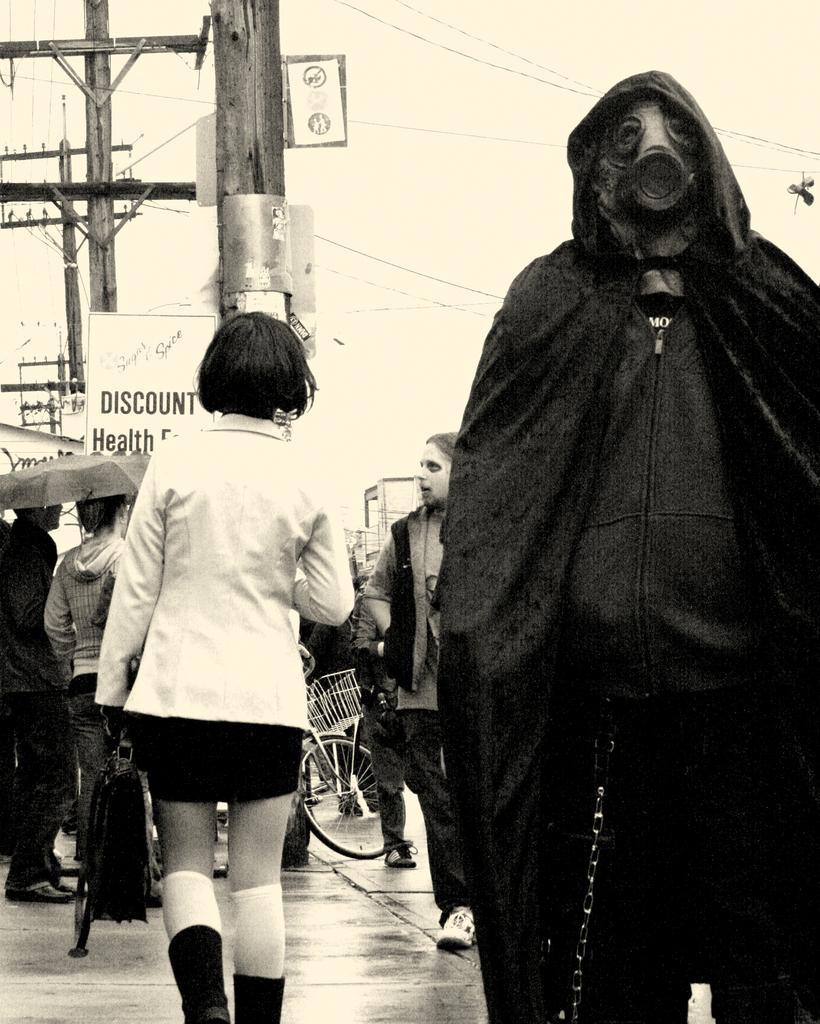What is the color scheme of the image? The image is black and white. What type of structure can be seen in the image? There is a current pole in the image. What other objects are present in the image? There are boards, a wheel, and an umbrella in the image. Are there any people in the image? Yes, there are people in the image. What is one person doing in the image? One person is holding a bag. What type of shirt is the chicken wearing in the image? There is no chicken present in the image, and therefore no shirt or any clothing item can be observed. 